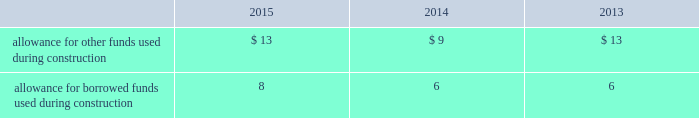The company recognizes accrued interest and penalties related to tax positions as a component of income tax expense and accounts for sales tax collected from customers and remitted to taxing authorities on a net basis .
Allowance for funds used during construction afudc is a non-cash credit to income with a corresponding charge to utility plant that represents the cost of borrowed funds or a return on equity funds devoted to plant under construction .
The regulated utility subsidiaries record afudc to the extent permitted by the pucs .
The portion of afudc attributable to borrowed funds is shown as a reduction of interest , net in the accompanying consolidated statements of operations .
Any portion of afudc attributable to equity funds would be included in other income ( expenses ) in the accompanying consolidated statements of operations .
Afudc is summarized in the table for the years ended december 31: .
Environmental costs the company 2019s water and wastewater operations are subject to u.s .
Federal , state , local and foreign requirements relating to environmental protection , and as such , the company periodically becomes subject to environmental claims in the normal course of business .
Environmental expenditures that relate to current operations or provide a future benefit are expensed or capitalized as appropriate .
Remediation costs that relate to an existing condition caused by past operations are accrued , on an undiscounted basis , when it is probable that these costs will be incurred and can be reasonably estimated .
Remediation costs accrued amounted to $ 1 and $ 2 as of december 31 , 2015 and 2014 , respectively .
The accrual relates entirely to a conservation agreement entered into by a subsidiary of the company with the national oceanic and atmospheric administration ( 201cnoaa 201d ) requiring the company to , among other provisions , implement certain measures to protect the steelhead trout and its habitat in the carmel river watershed in the state of california .
The company has agreed to pay $ 1 annually from 2010 to 2016 .
The company 2019s inception-to-date costs related to the noaa agreement were recorded in regulatory assets in the accompanying consolidated balance sheets as of december 31 , 2015 and 2014 and are expected to be fully recovered from customers in future rates .
Derivative financial instruments the company uses derivative financial instruments for purposes of hedging exposures to fluctuations in interest rates .
These derivative contracts are entered into for periods consistent with the related underlying exposures and do not constitute positions independent of those exposures .
The company does not enter into derivative contracts for speculative purposes and does not use leveraged instruments .
All derivatives are recognized on the balance sheet at fair value .
On the date the derivative contract is entered into , the company may designate the derivative as a hedge of the fair value of a recognized asset or liability ( fair-value hedge ) or a hedge of a forecasted transaction or of the variability of cash flows to be received or paid related to a recognized asset or liability ( cash-flow hedge ) .
Changes in the fair value of a fair-value hedge , along with the gain or loss on the underlying hedged item , are recorded in current-period earnings .
The effective portion of gains and losses on cash-flow hedges are recorded in other comprehensive income , until earnings are affected by the variability of cash flows .
Any ineffective portion of designated hedges is recognized in current-period earnings .
Cash flows from derivative contracts are included in net cash provided by operating activities in the accompanying consolidated statements of cash flows. .
What was the growth in allowance for other funds used during construction from 2013 to 2014? 
Rationale: the growth rate is the division of the change by the begin balance
Computations: ((9 - 13) / 9)
Answer: -0.44444. 